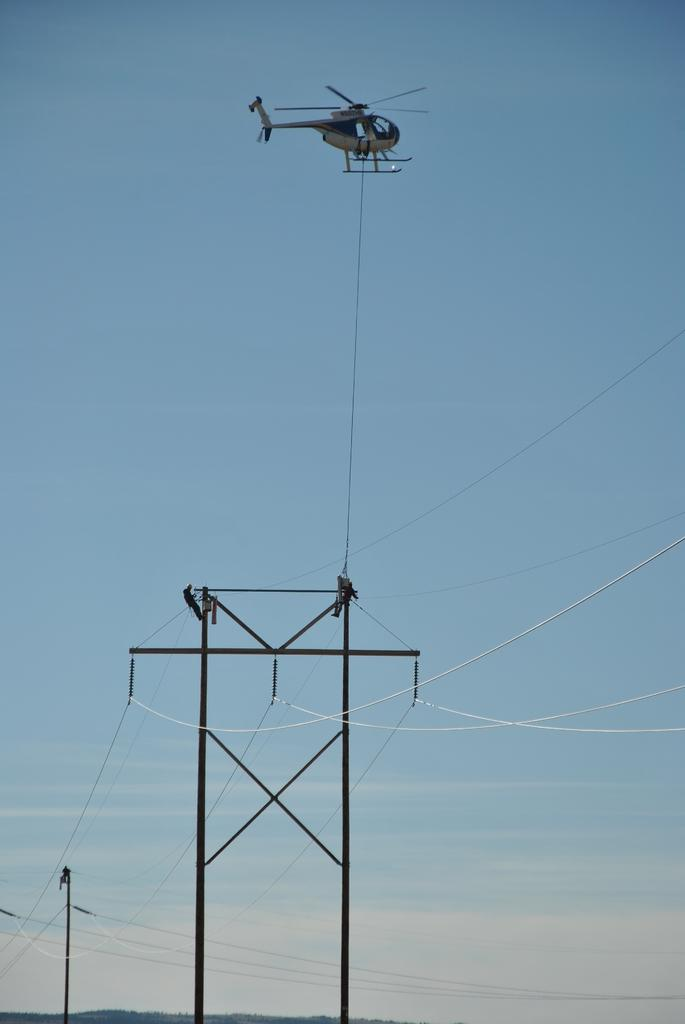What objects are present in the image that are related to electricity or communication? There are poles and wires in the image that are related to electricity or communication. How many people can be seen in the image? There are two people in the image. What is happening in the sky in the image? A helicopter is flying in the sky in the image. What type of oven can be seen in the image? There is no oven present in the image. What hand gestures are the people in the image making? The provided facts do not mention any hand gestures made by the people in the image. --- Facts: 1. There is a car in the image. 2. The car is parked on the street. 3. There are trees on the side of the street. 4. The sky is visible in the image. Absurd Topics: fish, hat, bicycle Conversation: What type of vehicle is in the image? There is a car in the image. Where is the car located in the image? The car is parked on the street. What type of vegetation is present on the side of the street? There are trees on the side of the street. What can be seen in the sky in the image? The sky is visible in the image. Reasoning: Let's think step by step in order to produce the conversation. We start by identifying the main subject in the image, which is the car. Then, we expand the conversation to include the location of the car, the type of vegetation present on the side of the street, and the sky visible in the image. Each question is designed to elicit a specific detail about the image that is known from the provided facts. Absurd Question/Answer: How many fish can be seen swimming in the image? There are no fish present in the image. What type of hat is the person in the image wearing? The provided facts do not mention any person or hat in the image. 